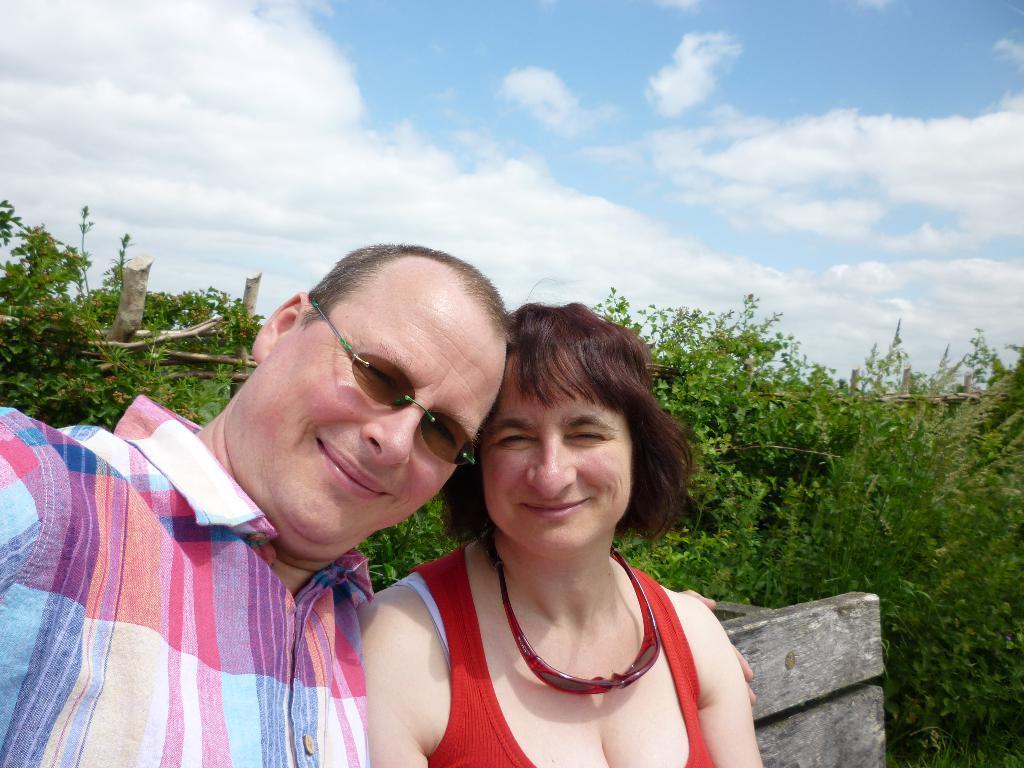In one or two sentences, can you explain what this image depicts? In this image I can see the two people with different color dresses. To the side I can see the wooden object. In the background I can see the plants, clouds and the sky. 